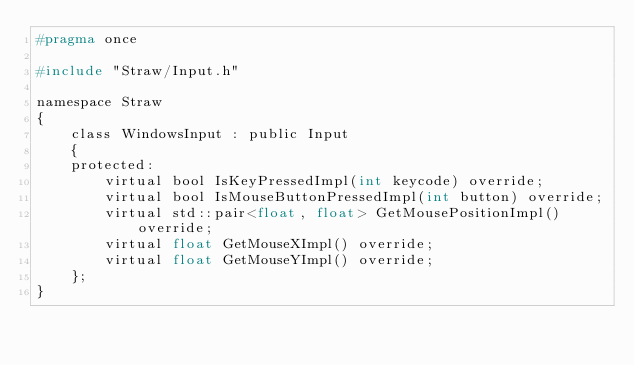Convert code to text. <code><loc_0><loc_0><loc_500><loc_500><_C_>#pragma once

#include "Straw/Input.h"

namespace Straw
{
	class WindowsInput : public Input
	{
	protected:
		virtual bool IsKeyPressedImpl(int keycode) override;
		virtual bool IsMouseButtonPressedImpl(int button) override;
		virtual std::pair<float, float> GetMousePositionImpl() override;
		virtual float GetMouseXImpl() override;
		virtual float GetMouseYImpl() override;
	};
}</code> 